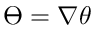<formula> <loc_0><loc_0><loc_500><loc_500>\varTheta = \nabla \theta</formula> 